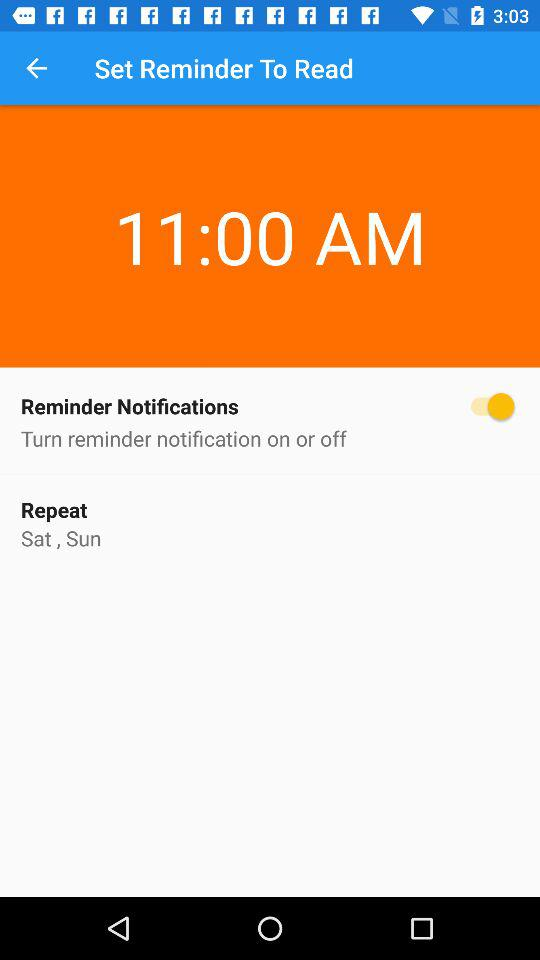When will the alarm repeat in a week? The alarm will repeat on Saturday and Sunday. 